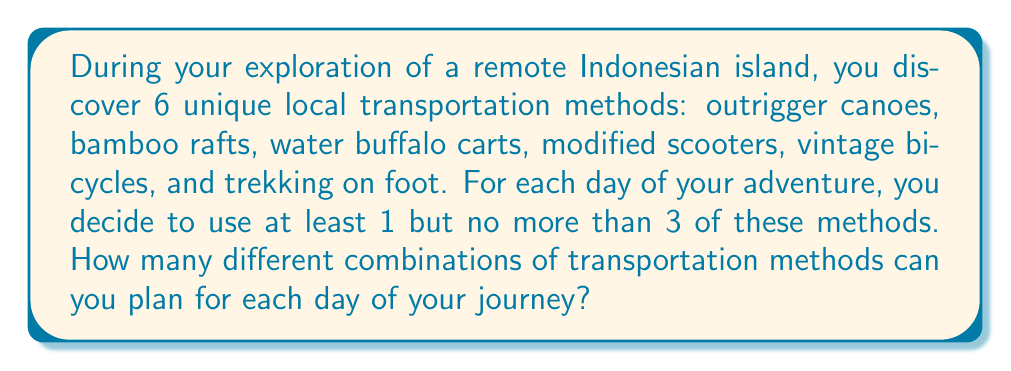Can you solve this math problem? Let's approach this step-by-step:

1) We need to calculate the number of combinations where we choose 1, 2, or 3 methods out of 6.

2) For 1 method: This is simply $\binom{6}{1}$

3) For 2 methods: This is $\binom{6}{2}$

4) For 3 methods: This is $\binom{6}{3}$

5) The total number of combinations is the sum of these:

   $$\binom{6}{1} + \binom{6}{2} + \binom{6}{3}$$

6) Let's calculate each:
   
   $\binom{6}{1} = \frac{6!}{1!(6-1)!} = \frac{6!}{1!5!} = 6$
   
   $\binom{6}{2} = \frac{6!}{2!(6-2)!} = \frac{6!}{2!4!} = 15$
   
   $\binom{6}{3} = \frac{6!}{3!(6-3)!} = \frac{6!}{3!3!} = 20$

7) Now, sum these up:

   $$6 + 15 + 20 = 41$$

Therefore, there are 41 different combinations of transportation methods you can plan for each day.
Answer: 41 